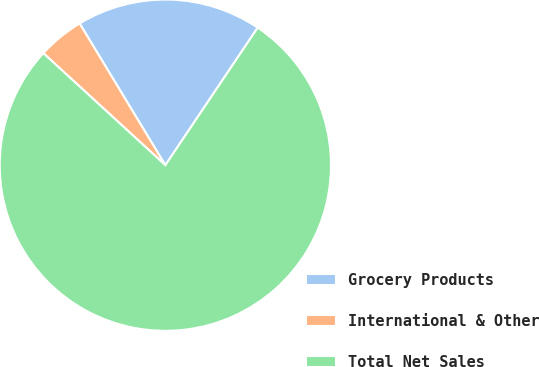<chart> <loc_0><loc_0><loc_500><loc_500><pie_chart><fcel>Grocery Products<fcel>International & Other<fcel>Total Net Sales<nl><fcel>18.07%<fcel>4.52%<fcel>77.41%<nl></chart> 